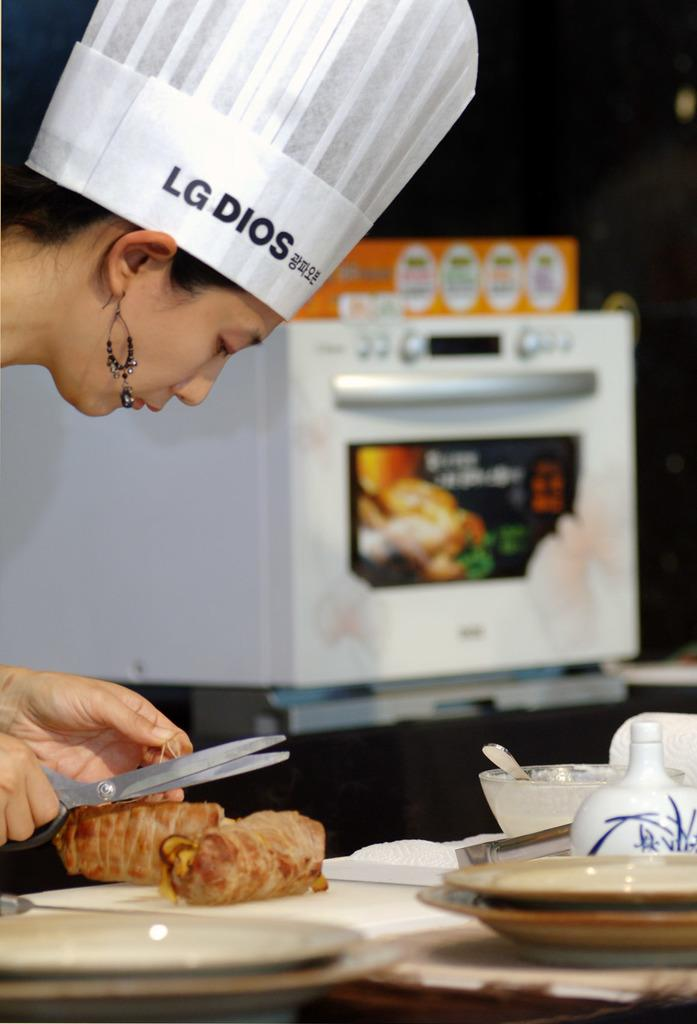<image>
Provide a brief description of the given image. A chef with  an LG Dios hat using scissors in her hand near a plate of food. 